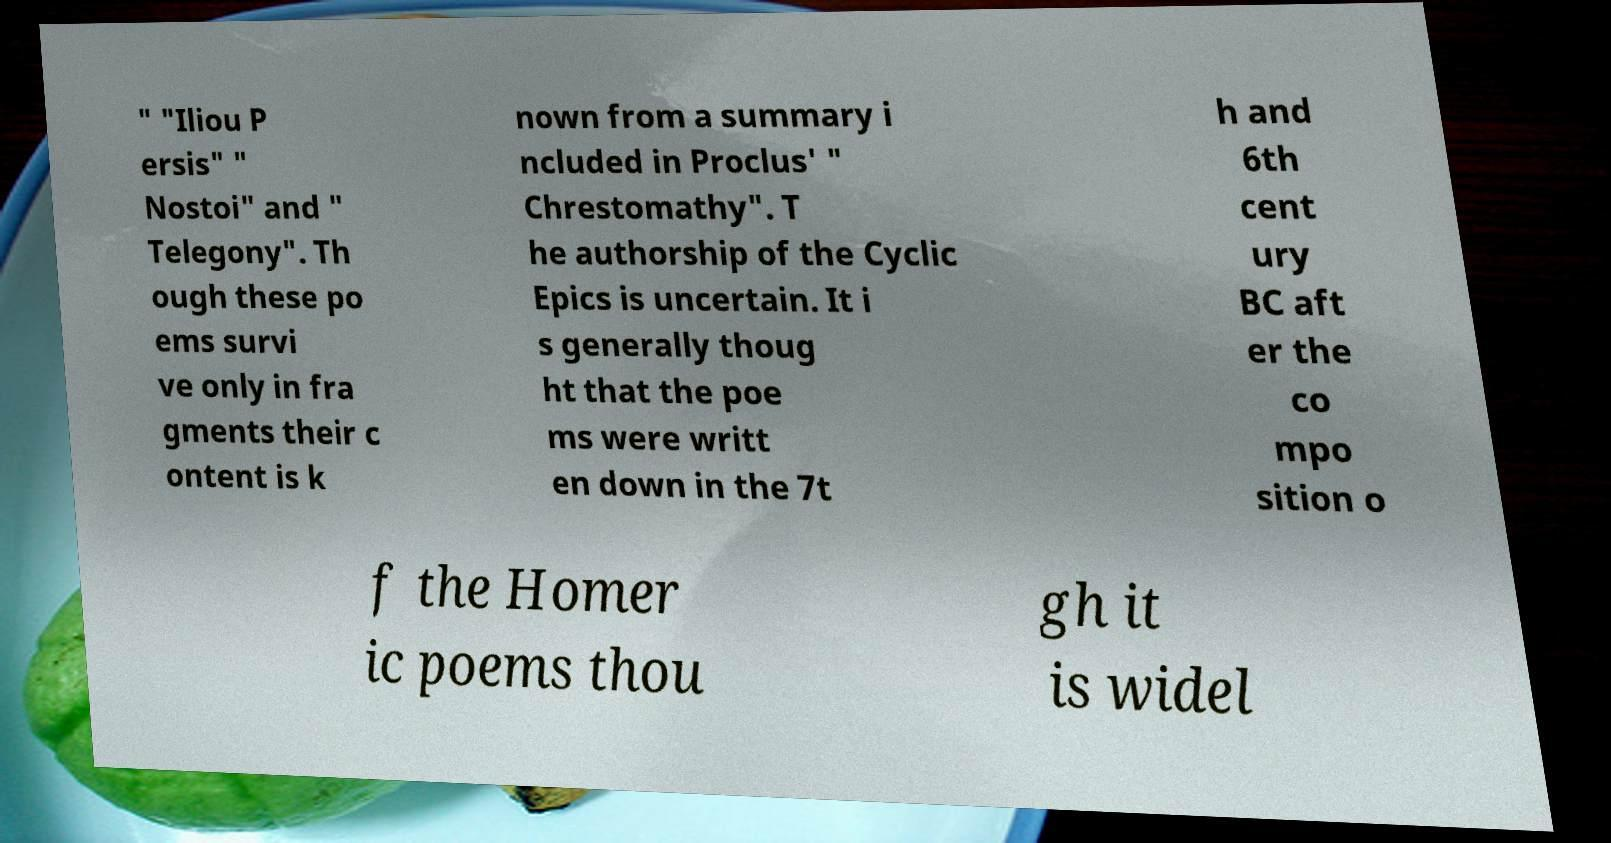Could you extract and type out the text from this image? " "Iliou P ersis" " Nostoi" and " Telegony". Th ough these po ems survi ve only in fra gments their c ontent is k nown from a summary i ncluded in Proclus' " Chrestomathy". T he authorship of the Cyclic Epics is uncertain. It i s generally thoug ht that the poe ms were writt en down in the 7t h and 6th cent ury BC aft er the co mpo sition o f the Homer ic poems thou gh it is widel 